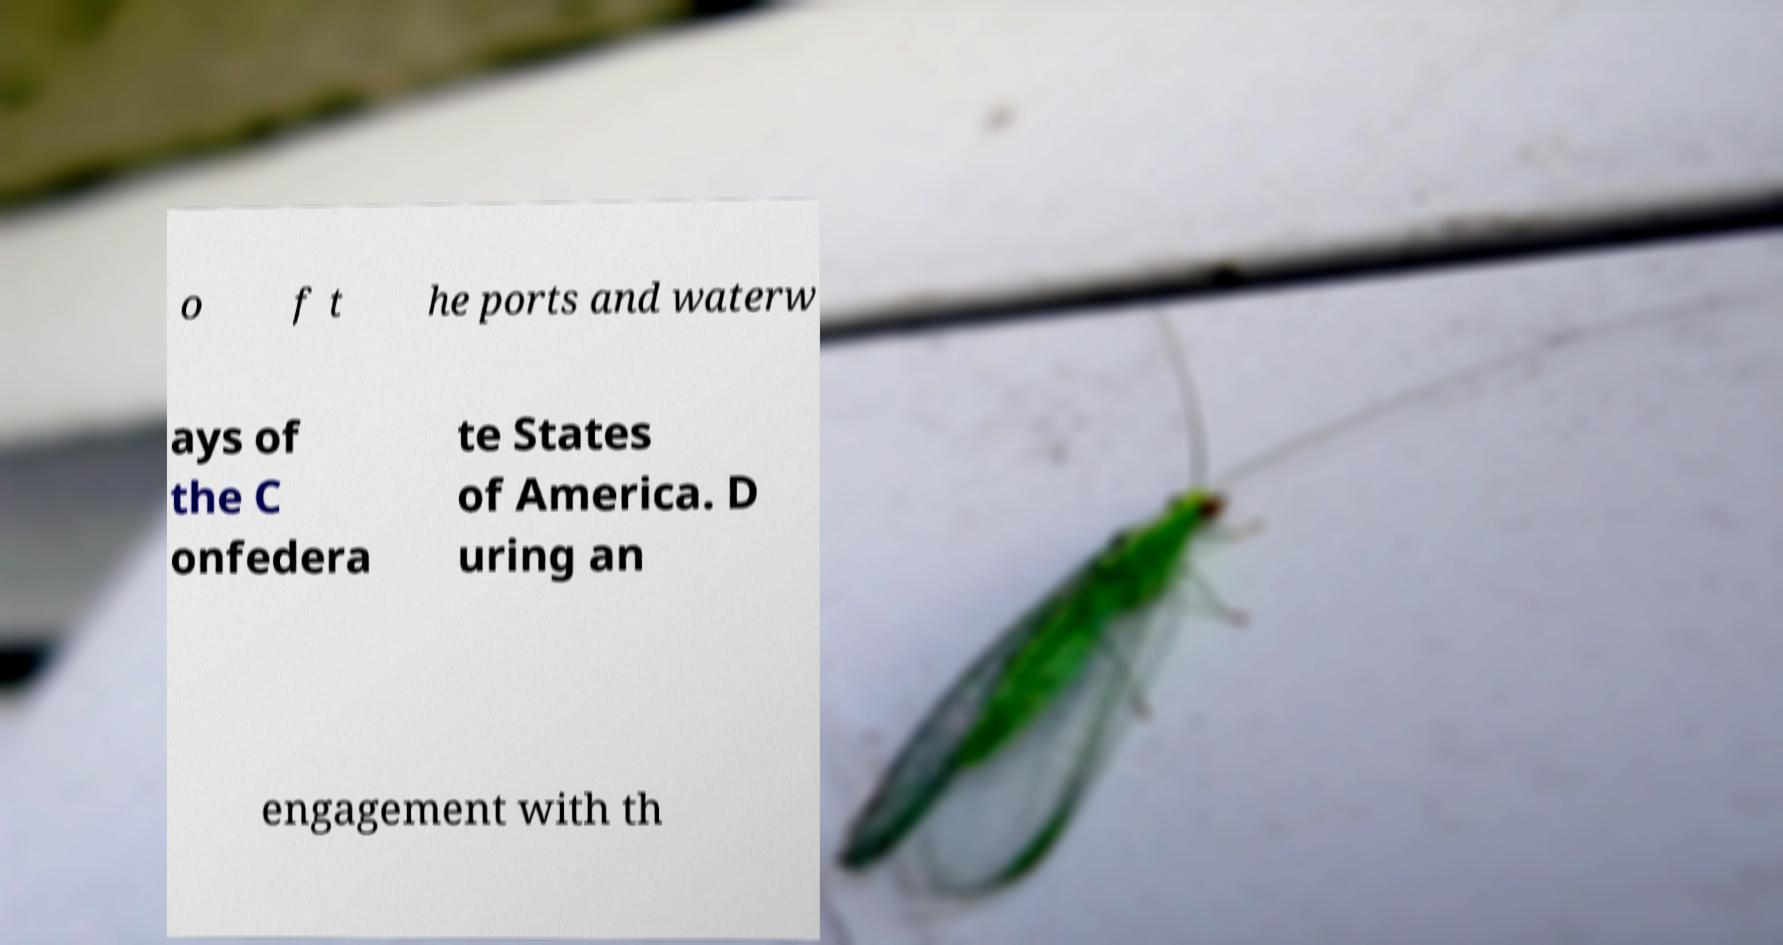Please identify and transcribe the text found in this image. o f t he ports and waterw ays of the C onfedera te States of America. D uring an engagement with th 